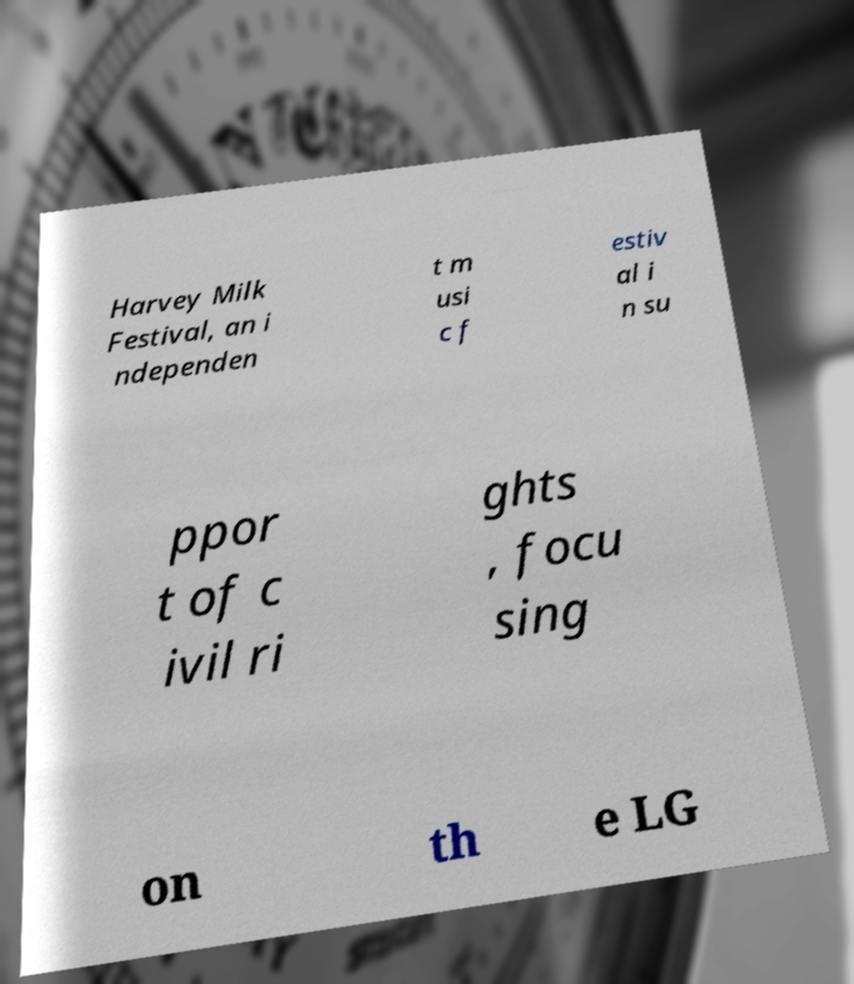Please read and relay the text visible in this image. What does it say? Harvey Milk Festival, an i ndependen t m usi c f estiv al i n su ppor t of c ivil ri ghts , focu sing on th e LG 